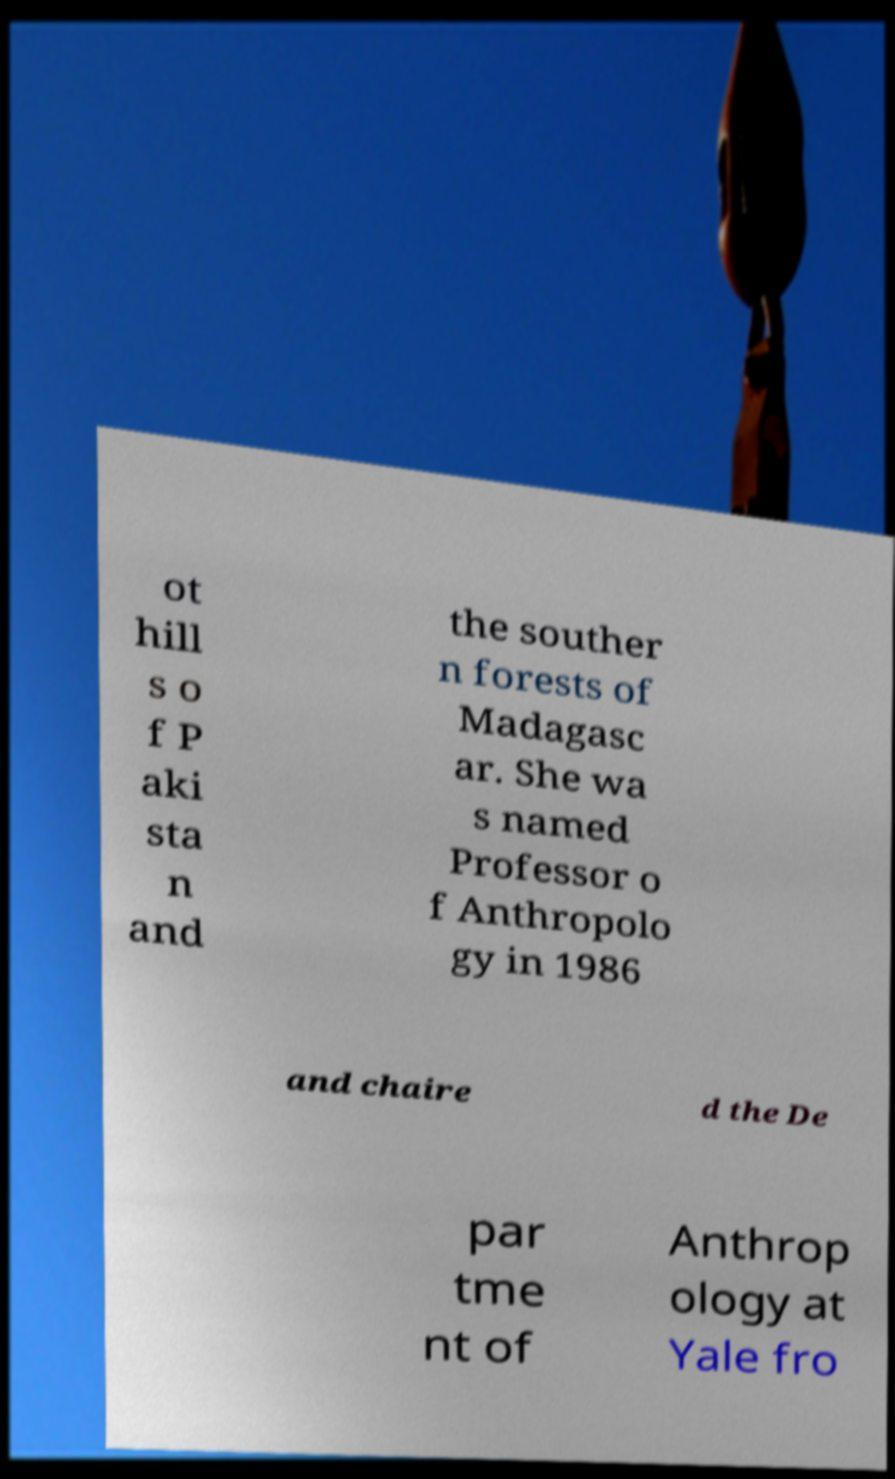Please read and relay the text visible in this image. What does it say? ot hill s o f P aki sta n and the souther n forests of Madagasc ar. She wa s named Professor o f Anthropolo gy in 1986 and chaire d the De par tme nt of Anthrop ology at Yale fro 